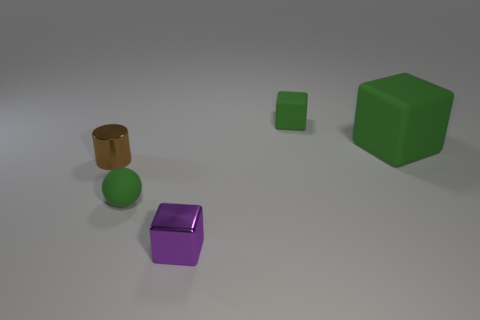Subtract all gray cylinders. How many green cubes are left? 2 Subtract all small green blocks. How many blocks are left? 2 Add 2 large yellow matte blocks. How many objects exist? 7 Subtract all cylinders. How many objects are left? 4 Subtract all green blocks. How many blocks are left? 1 Subtract all small green blocks. Subtract all tiny purple metal objects. How many objects are left? 3 Add 1 tiny cylinders. How many tiny cylinders are left? 2 Add 3 small spheres. How many small spheres exist? 4 Subtract 0 brown cubes. How many objects are left? 5 Subtract all red blocks. Subtract all gray cylinders. How many blocks are left? 3 